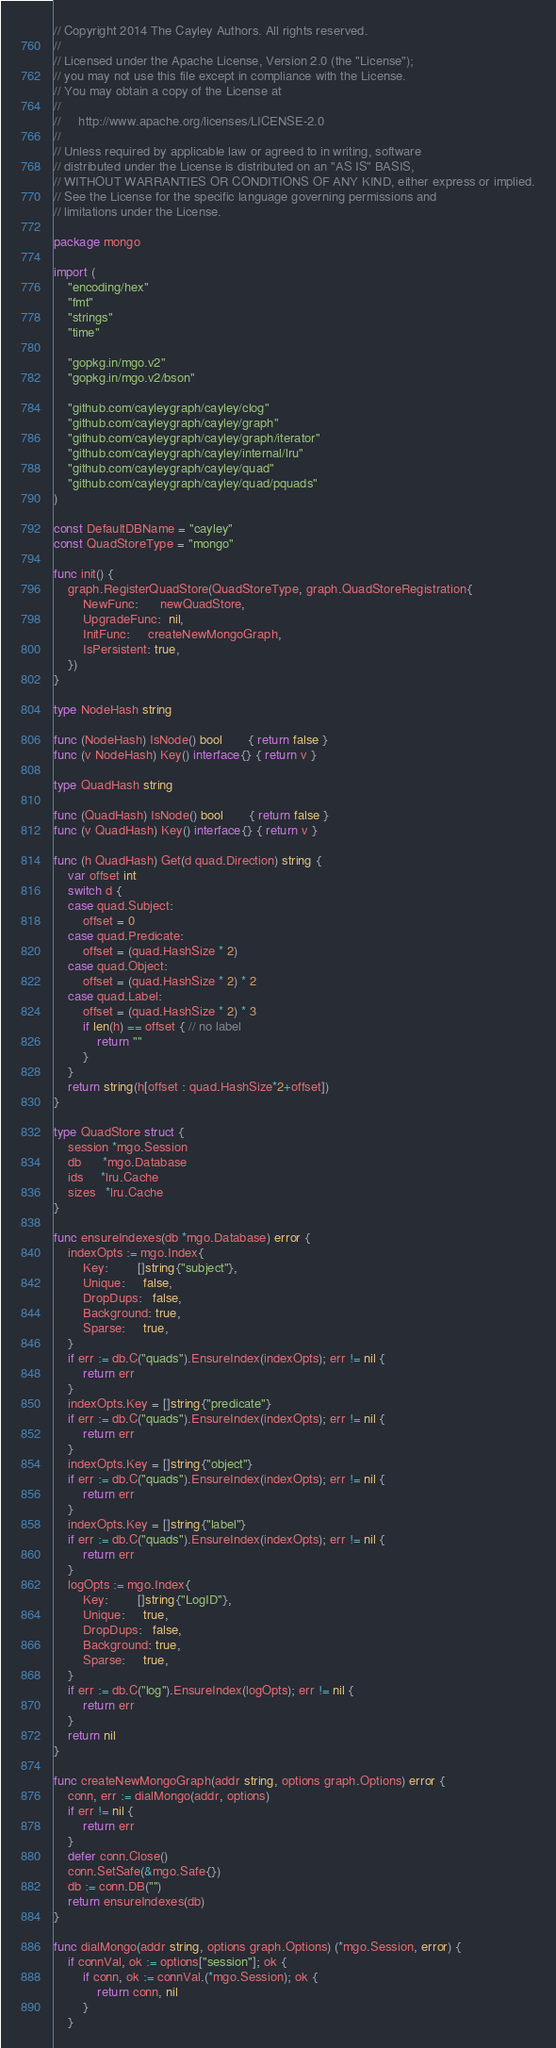Convert code to text. <code><loc_0><loc_0><loc_500><loc_500><_Go_>// Copyright 2014 The Cayley Authors. All rights reserved.
//
// Licensed under the Apache License, Version 2.0 (the "License");
// you may not use this file except in compliance with the License.
// You may obtain a copy of the License at
//
//     http://www.apache.org/licenses/LICENSE-2.0
//
// Unless required by applicable law or agreed to in writing, software
// distributed under the License is distributed on an "AS IS" BASIS,
// WITHOUT WARRANTIES OR CONDITIONS OF ANY KIND, either express or implied.
// See the License for the specific language governing permissions and
// limitations under the License.

package mongo

import (
	"encoding/hex"
	"fmt"
	"strings"
	"time"

	"gopkg.in/mgo.v2"
	"gopkg.in/mgo.v2/bson"

	"github.com/cayleygraph/cayley/clog"
	"github.com/cayleygraph/cayley/graph"
	"github.com/cayleygraph/cayley/graph/iterator"
	"github.com/cayleygraph/cayley/internal/lru"
	"github.com/cayleygraph/cayley/quad"
	"github.com/cayleygraph/cayley/quad/pquads"
)

const DefaultDBName = "cayley"
const QuadStoreType = "mongo"

func init() {
	graph.RegisterQuadStore(QuadStoreType, graph.QuadStoreRegistration{
		NewFunc:      newQuadStore,
		UpgradeFunc:  nil,
		InitFunc:     createNewMongoGraph,
		IsPersistent: true,
	})
}

type NodeHash string

func (NodeHash) IsNode() bool       { return false }
func (v NodeHash) Key() interface{} { return v }

type QuadHash string

func (QuadHash) IsNode() bool       { return false }
func (v QuadHash) Key() interface{} { return v }

func (h QuadHash) Get(d quad.Direction) string {
	var offset int
	switch d {
	case quad.Subject:
		offset = 0
	case quad.Predicate:
		offset = (quad.HashSize * 2)
	case quad.Object:
		offset = (quad.HashSize * 2) * 2
	case quad.Label:
		offset = (quad.HashSize * 2) * 3
		if len(h) == offset { // no label
			return ""
		}
	}
	return string(h[offset : quad.HashSize*2+offset])
}

type QuadStore struct {
	session *mgo.Session
	db      *mgo.Database
	ids     *lru.Cache
	sizes   *lru.Cache
}

func ensureIndexes(db *mgo.Database) error {
	indexOpts := mgo.Index{
		Key:        []string{"subject"},
		Unique:     false,
		DropDups:   false,
		Background: true,
		Sparse:     true,
	}
	if err := db.C("quads").EnsureIndex(indexOpts); err != nil {
		return err
	}
	indexOpts.Key = []string{"predicate"}
	if err := db.C("quads").EnsureIndex(indexOpts); err != nil {
		return err
	}
	indexOpts.Key = []string{"object"}
	if err := db.C("quads").EnsureIndex(indexOpts); err != nil {
		return err
	}
	indexOpts.Key = []string{"label"}
	if err := db.C("quads").EnsureIndex(indexOpts); err != nil {
		return err
	}
	logOpts := mgo.Index{
		Key:        []string{"LogID"},
		Unique:     true,
		DropDups:   false,
		Background: true,
		Sparse:     true,
	}
	if err := db.C("log").EnsureIndex(logOpts); err != nil {
		return err
	}
	return nil
}

func createNewMongoGraph(addr string, options graph.Options) error {
	conn, err := dialMongo(addr, options)
	if err != nil {
		return err
	}
	defer conn.Close()
	conn.SetSafe(&mgo.Safe{})
	db := conn.DB("")
	return ensureIndexes(db)
}

func dialMongo(addr string, options graph.Options) (*mgo.Session, error) {
	if connVal, ok := options["session"]; ok {
		if conn, ok := connVal.(*mgo.Session); ok {
			return conn, nil
		}
	}</code> 